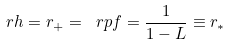<formula> <loc_0><loc_0><loc_500><loc_500>\ r h = r _ { + } = \ r p f = \frac { 1 } { 1 - L } \equiv r _ { * }</formula> 